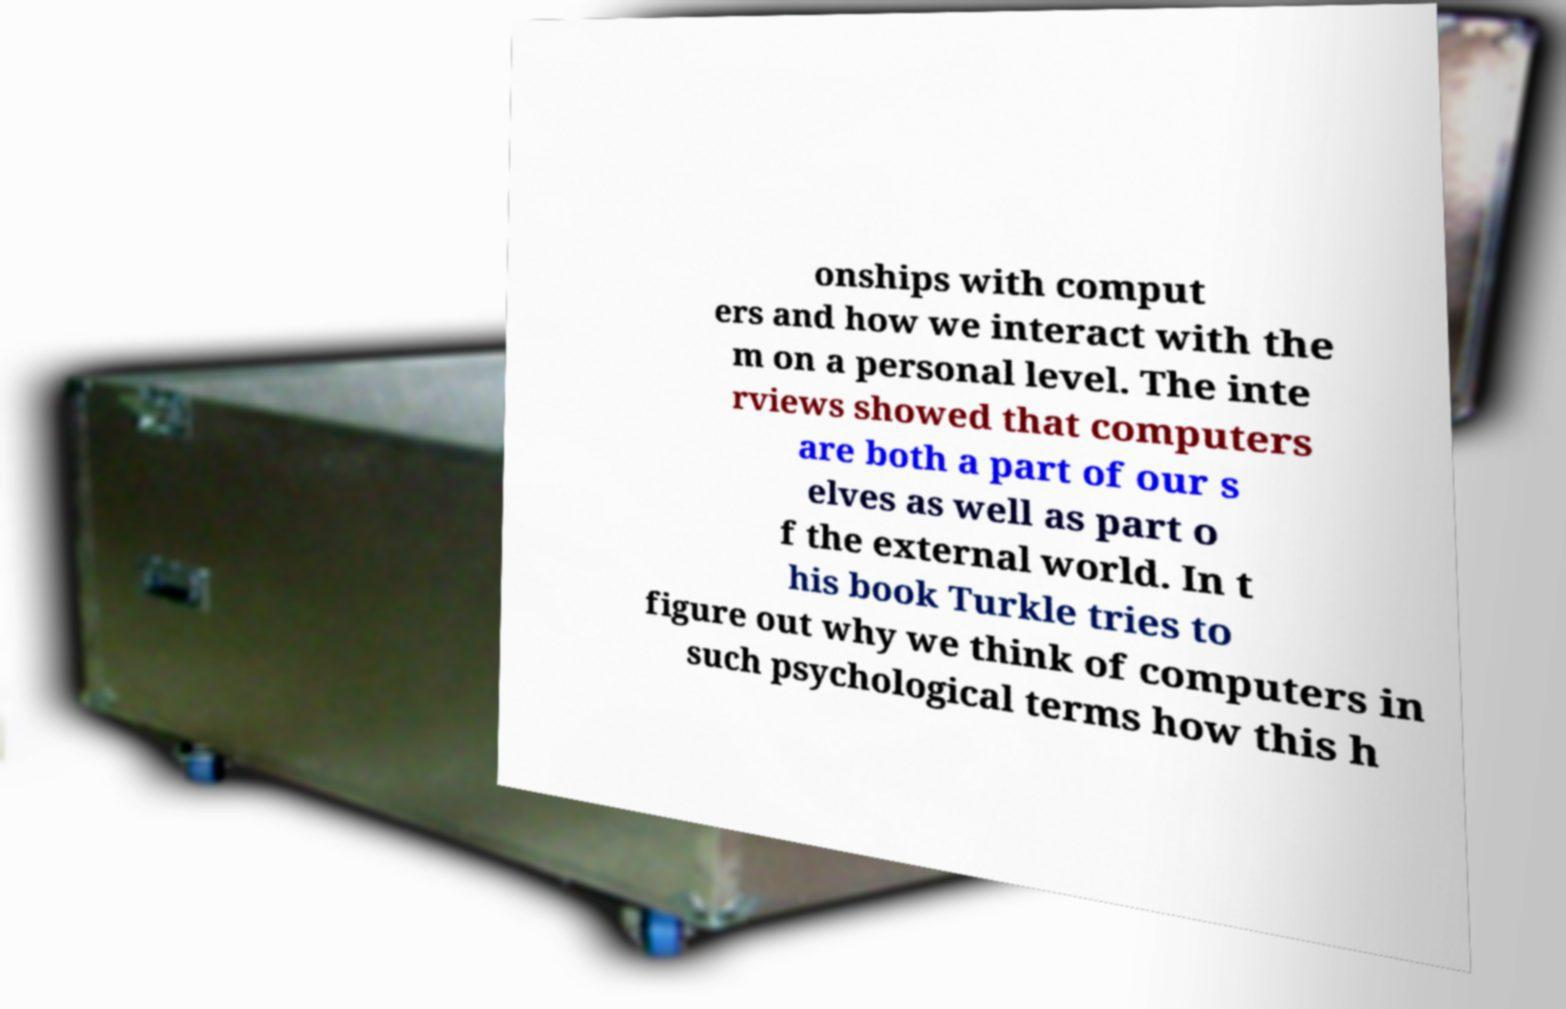I need the written content from this picture converted into text. Can you do that? onships with comput ers and how we interact with the m on a personal level. The inte rviews showed that computers are both a part of our s elves as well as part o f the external world. In t his book Turkle tries to figure out why we think of computers in such psychological terms how this h 